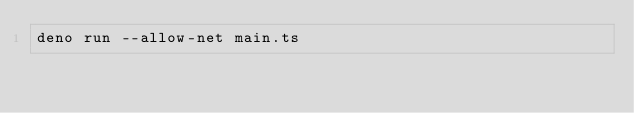Convert code to text. <code><loc_0><loc_0><loc_500><loc_500><_Bash_>deno run --allow-net main.ts
</code> 